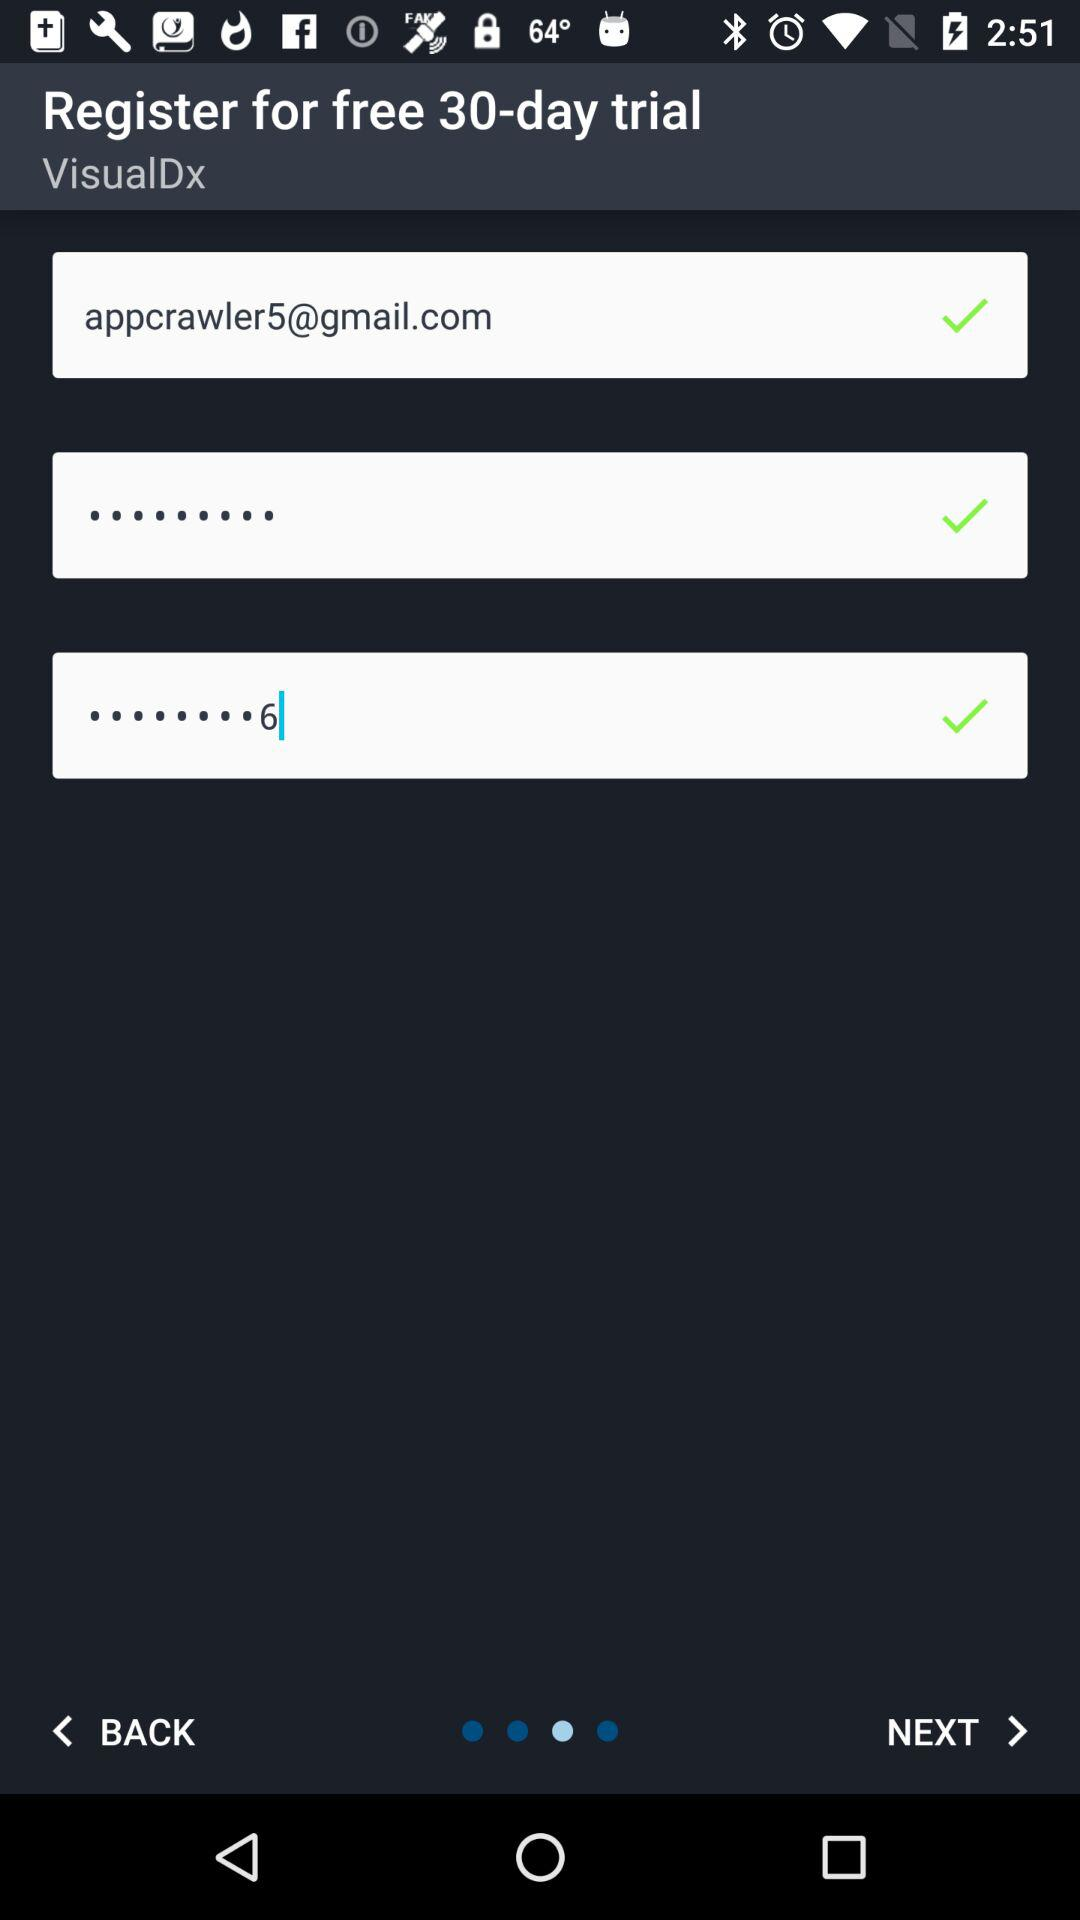How many days are there in the free trial? There are 30 days in the free trail. 